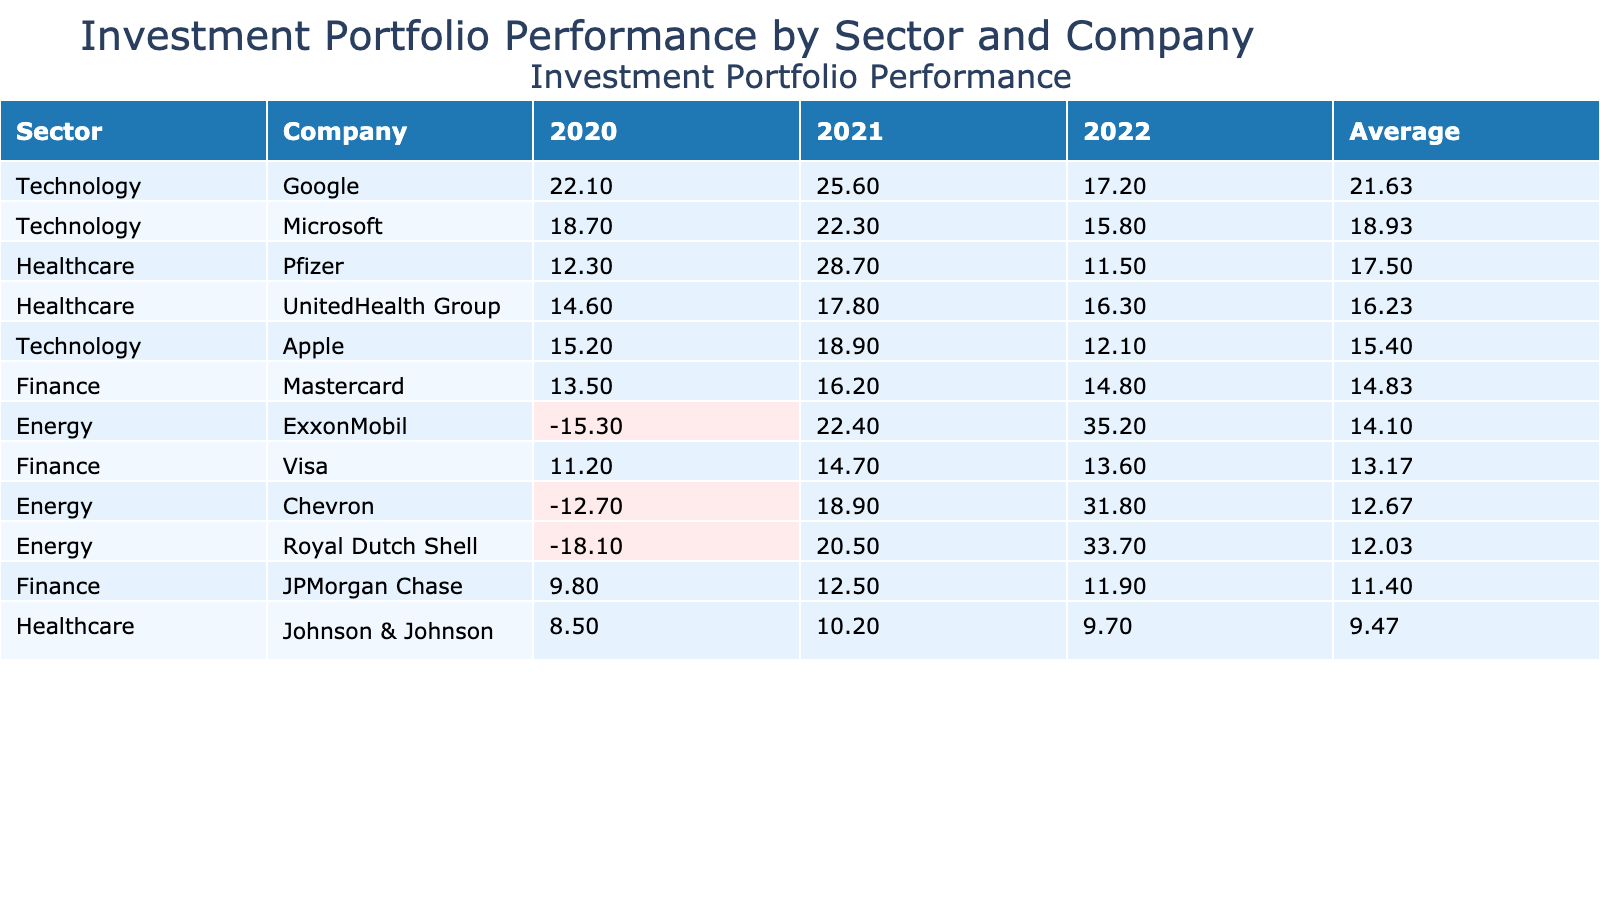What is the highest return percentage achieved by a company in the Technology sector in 2021? The highest return percentage for the Technology sector in 2021 is found by looking through the return percentages of Apple, Microsoft, and Google in that year. Apple has 18.9, Microsoft has 22.3, and Google has 25.6. Hence, the highest is 25.6 from Google.
Answer: 25.6 Which company had the lowest return percentage over the three years in the Finance sector? In the Finance sector, the return percentages for each company over three years need to be compared. JPMorgan Chase had return percentages of 9.8, 12.5, and 11.9, Visa had 11.2, 14.7, and 13.6, and Mastercard had 13.5, 16.2, and 14.8. The lowest average return is from JPMorgan Chase at (9.8 + 12.5 + 11.9) / 3 = 11.47.
Answer: JPMorgan Chase Is there any company in the Energy sector that yielded a positive return in 2020? A look at the Energy sector's companies' return percentages shows ExxonMobil at -15.3, Chevron at -12.7, and Royal Dutch Shell at -18.1. All of these values are negative, indicating no company yielded a positive return.
Answer: No What is the average return percentage across all companies in the Healthcare sector for 2021? To find the average return percentage in the Healthcare sector for 2021, we take the return percentages of Johnson & Johnson (10.2), Pfizer (28.7), and UnitedHealth Group (17.8). Summing these gives 10.2 + 28.7 + 17.8 = 56.7, and dividing by the number of companies (3) results in an average of 18.9.
Answer: 18.9 In which year did the Technology sector achieve the highest average return percentage? The average return percentages for the Technology sector in each year are calculated. In 2020, it is (15.2 + 18.7 + 22.1) / 3 = 18.67; in 2021, it is (18.9 + 22.3 + 25.6) / 3 = 22.23; and in 2022, it's (12.1 + 15.8 + 17.2) / 3 = 15.37. The highest average return percentage was in 2021, at 22.23.
Answer: 2021 Which company in the Energy sector had the highest return percentage in 2022? The Energy sector's return percentages in 2022 are checked: ExxonMobil (35.2), Chevron (31.8), and Royal Dutch Shell (33.7). The highest return percentage is 35.2 from ExxonMobil.
Answer: ExxonMobil 